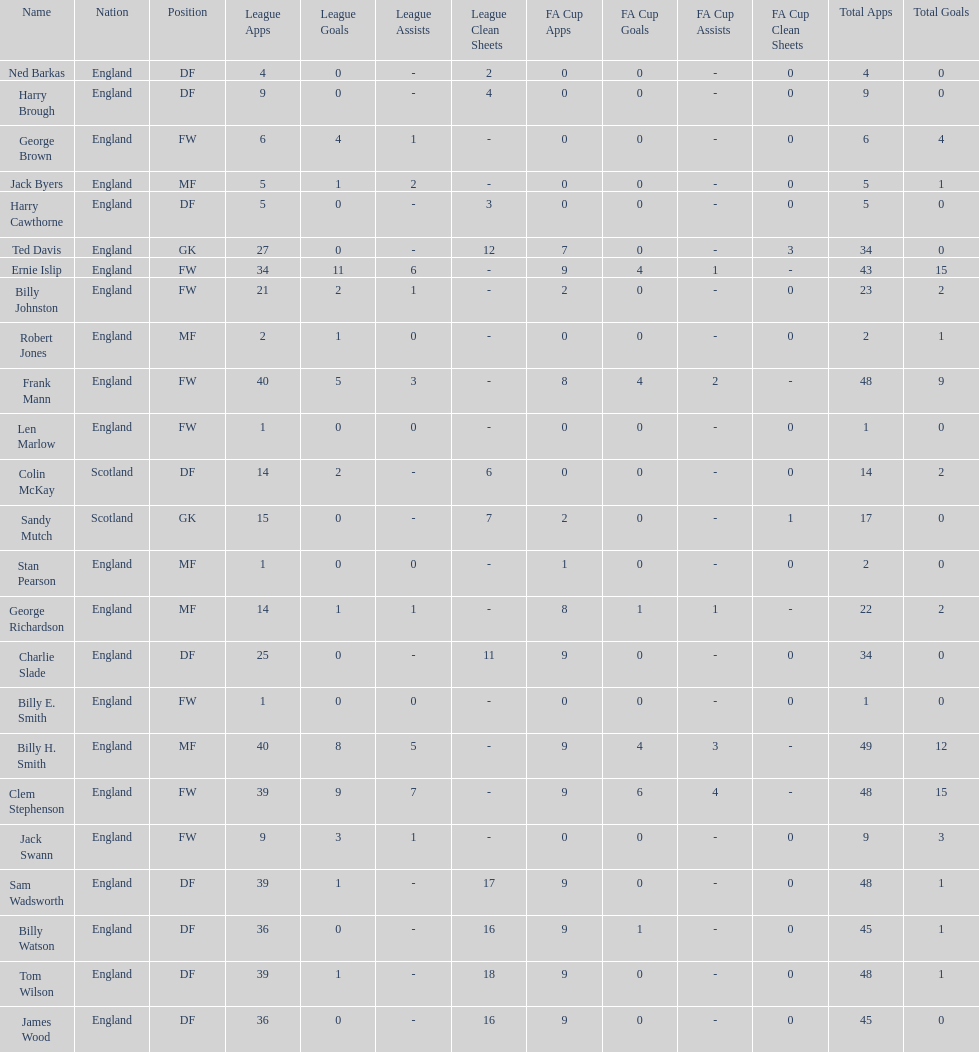Which name appears first in the list? Ned Barkas. 